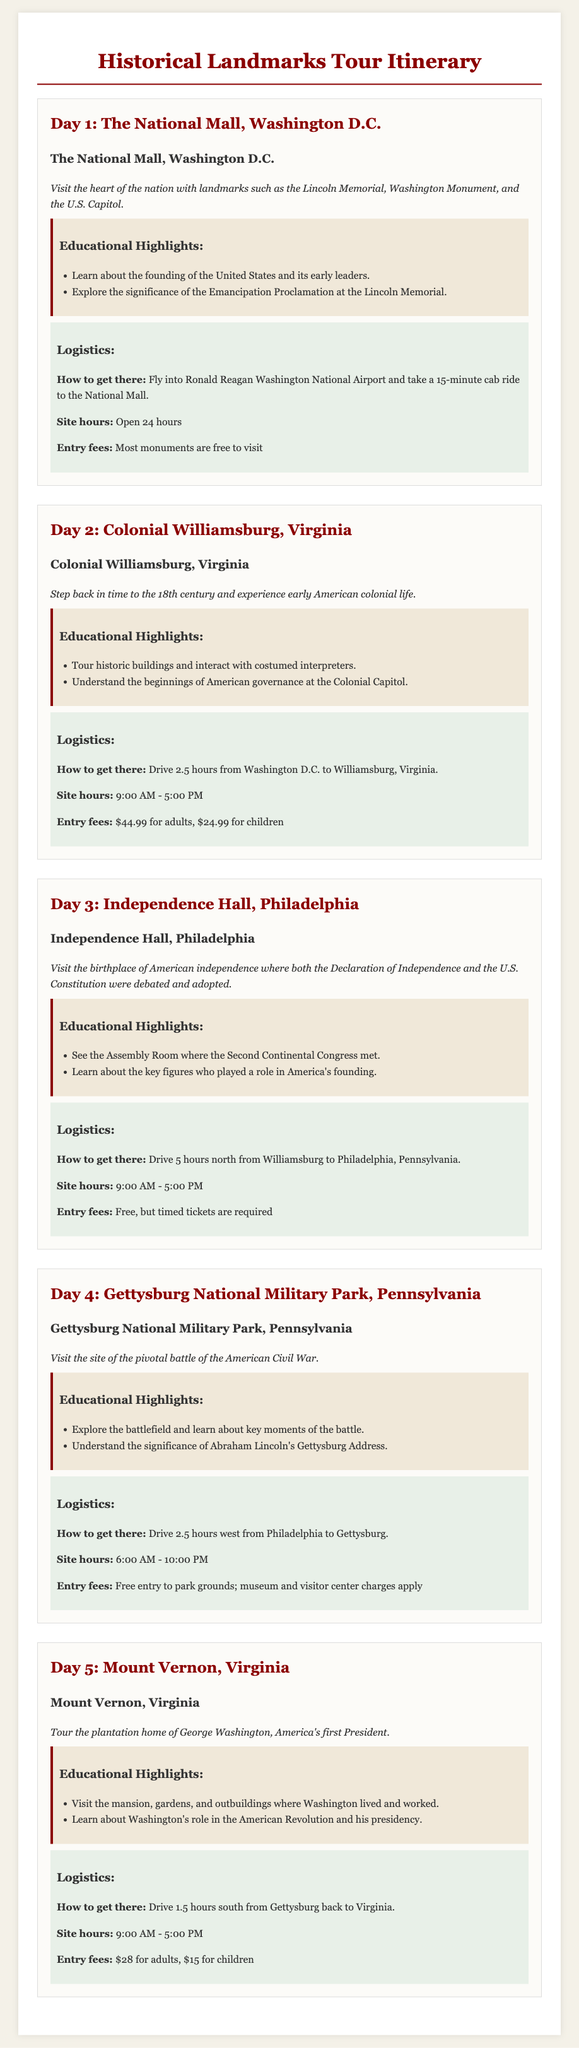What is the title of the document? The title is displayed prominently at the top of the document.
Answer: Historical Landmarks Tour Itinerary How long is the site hours for Independence Hall? The site hours are listed under logistics for Independence Hall.
Answer: 9:00 AM - 5:00 PM What is the entry fee for Colonial Williamsburg for adults? The entry fee is specified under the logistics for Colonial Williamsburg.
Answer: $44.99 Which day is dedicated to Mount Vernon? The days are numbered and labeled accordingly.
Answer: Day 5 What significant document is associated with the Lincoln Memorial? The document is mentioned in the educational highlights for Day 1.
Answer: Emancipation Proclamation How many hours does it take to drive from Williamsburg to Philadelphia? The travel time is provided in the logistics section of the itinerary.
Answer: 5 hours What is the main theme of the tour? The overall theme can be inferred from the title and site descriptions.
Answer: Historical landmarks What can you learn about at Mount Vernon? The educational highlights for Mount Vernon provide insight into the content.
Answer: Washington's role in the American Revolution and his presidency What is the starting time for site hours at Gettysburg National Military Park? The hours are specified under logistics for Gettysburg.
Answer: 6:00 AM 